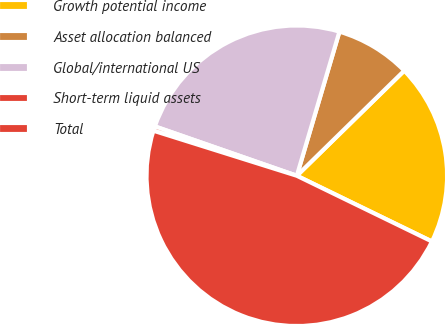Convert chart to OTSL. <chart><loc_0><loc_0><loc_500><loc_500><pie_chart><fcel>Growth potential income<fcel>Asset allocation balanced<fcel>Global/international US<fcel>Short-term liquid assets<fcel>Total<nl><fcel>19.53%<fcel>8.1%<fcel>24.25%<fcel>0.48%<fcel>47.64%<nl></chart> 